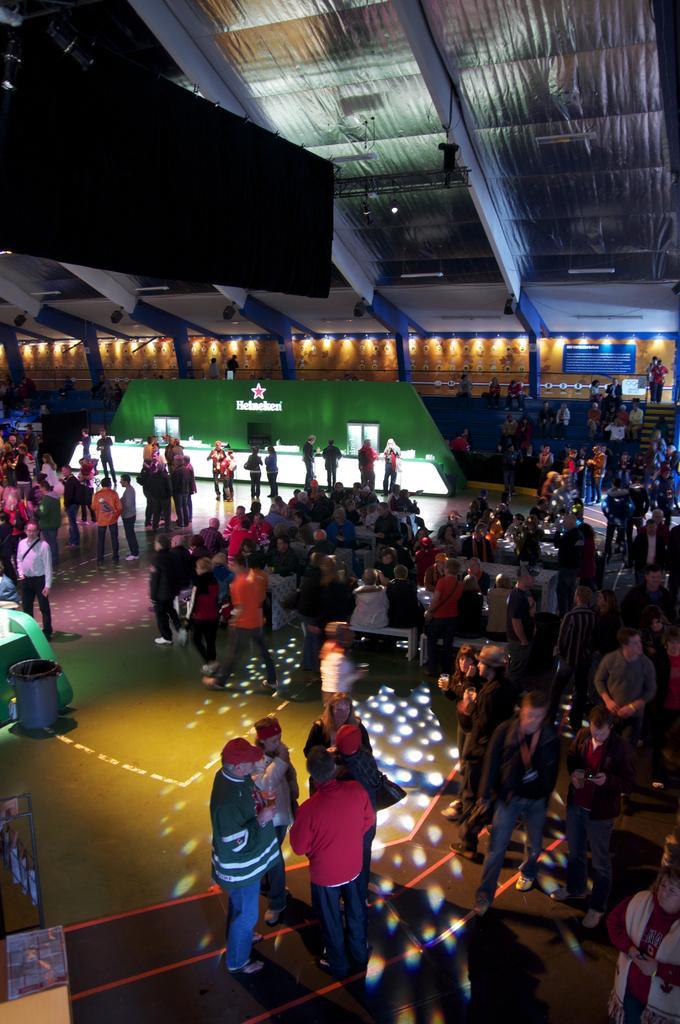Describe this image in one or two sentences. In this picture there are people on the right and left side of the image, there are spotlights in the center of the image and there is a roof at the top side of the image. 